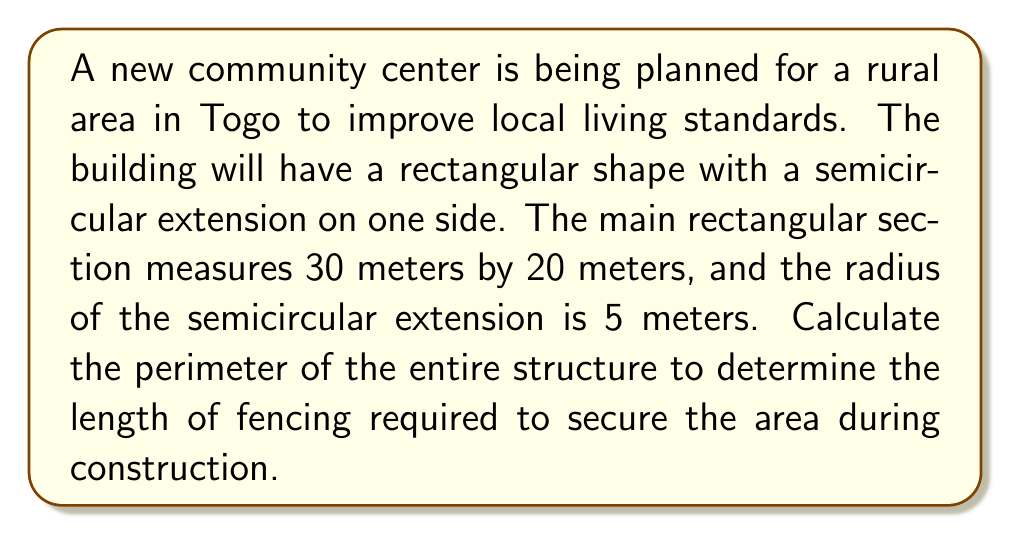Give your solution to this math problem. Let's break this down step-by-step:

1) First, we need to calculate the perimeter of the rectangular part:
   $$P_{rectangle} = 2(l + w)$$
   where $l$ is length and $w$ is width
   $$P_{rectangle} = 2(30 + 20) = 2(50) = 100\text{ meters}$$

2) Now, we need to subtract the width of the rectangular part where the semicircle is attached:
   $$100 - 10 = 90\text{ meters}$$

3) For the semicircular part, we need to calculate its arc length:
   The formula for the arc length of a semicircle is $\pi r$, where $r$ is the radius
   $$\text{Arc length} = \pi \cdot 5 = 5\pi\text{ meters}$$

4) Now, we can add the remaining rectangular perimeter and the semicircular arc length:
   $$\text{Total perimeter} = 90 + 5\pi\text{ meters}$$

5) If we want to express this in decimal form:
   $$90 + 5\pi \approx 90 + 15.71 = 105.71\text{ meters}$$

[asy]
unitsize(4mm);
fill((-15,-10)--(15,-10)--(15,10)--(-15,10)--cycle,lightgray);
fill(arc((15,0),5,90,270),lightgray);
draw((-15,-10)--(15,-10)--(15,10)--(-15,10)--cycle);
draw(arc((15,0),5,90,270));
label("30m", (0,-10), S);
label("20m", (-15,0), W);
label("5m", (15,2.5), E);
[/asy]
Answer: $90 + 5\pi\text{ meters}$ or approximately $105.71\text{ meters}$ 